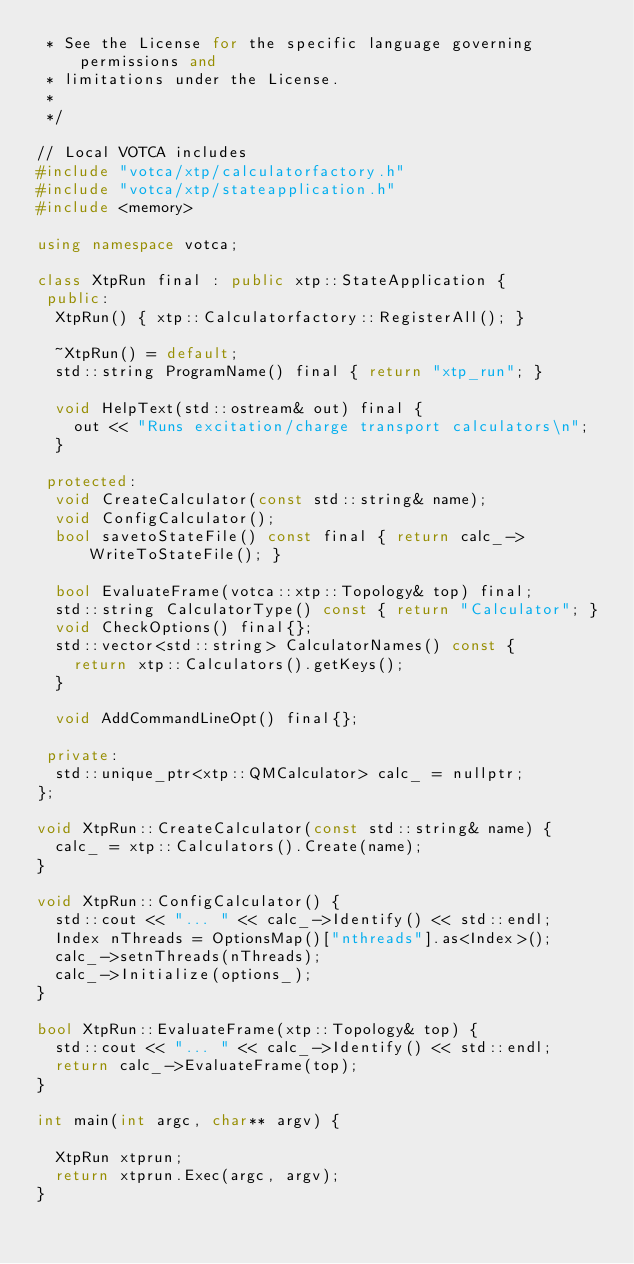<code> <loc_0><loc_0><loc_500><loc_500><_C++_> * See the License for the specific language governing permissions and
 * limitations under the License.
 *
 */

// Local VOTCA includes
#include "votca/xtp/calculatorfactory.h"
#include "votca/xtp/stateapplication.h"
#include <memory>

using namespace votca;

class XtpRun final : public xtp::StateApplication {
 public:
  XtpRun() { xtp::Calculatorfactory::RegisterAll(); }

  ~XtpRun() = default;
  std::string ProgramName() final { return "xtp_run"; }

  void HelpText(std::ostream& out) final {
    out << "Runs excitation/charge transport calculators\n";
  }

 protected:
  void CreateCalculator(const std::string& name);
  void ConfigCalculator();
  bool savetoStateFile() const final { return calc_->WriteToStateFile(); }

  bool EvaluateFrame(votca::xtp::Topology& top) final;
  std::string CalculatorType() const { return "Calculator"; }
  void CheckOptions() final{};
  std::vector<std::string> CalculatorNames() const {
    return xtp::Calculators().getKeys();
  }

  void AddCommandLineOpt() final{};

 private:
  std::unique_ptr<xtp::QMCalculator> calc_ = nullptr;
};

void XtpRun::CreateCalculator(const std::string& name) {
  calc_ = xtp::Calculators().Create(name);
}

void XtpRun::ConfigCalculator() {
  std::cout << "... " << calc_->Identify() << std::endl;
  Index nThreads = OptionsMap()["nthreads"].as<Index>();
  calc_->setnThreads(nThreads);
  calc_->Initialize(options_);
}

bool XtpRun::EvaluateFrame(xtp::Topology& top) {
  std::cout << "... " << calc_->Identify() << std::endl;
  return calc_->EvaluateFrame(top);
}

int main(int argc, char** argv) {

  XtpRun xtprun;
  return xtprun.Exec(argc, argv);
}
</code> 